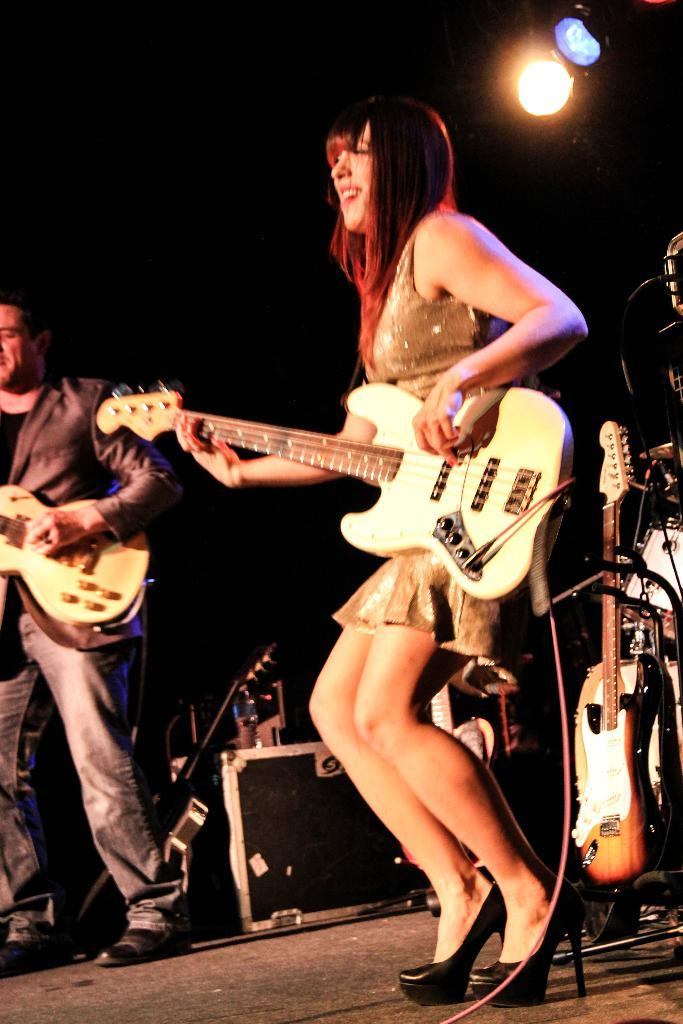What are the woman and the man in the image doing? The woman and the man are playing the guitar. What are they holding while playing the guitar? They are holding a guitar. Can you describe the lighting in the image? There is a light above the woman and the man. How many jellyfish can be seen swimming in the image? There are no jellyfish present in the image. What color is the sock that the man is wearing in the image? There is no sock visible in the image. 